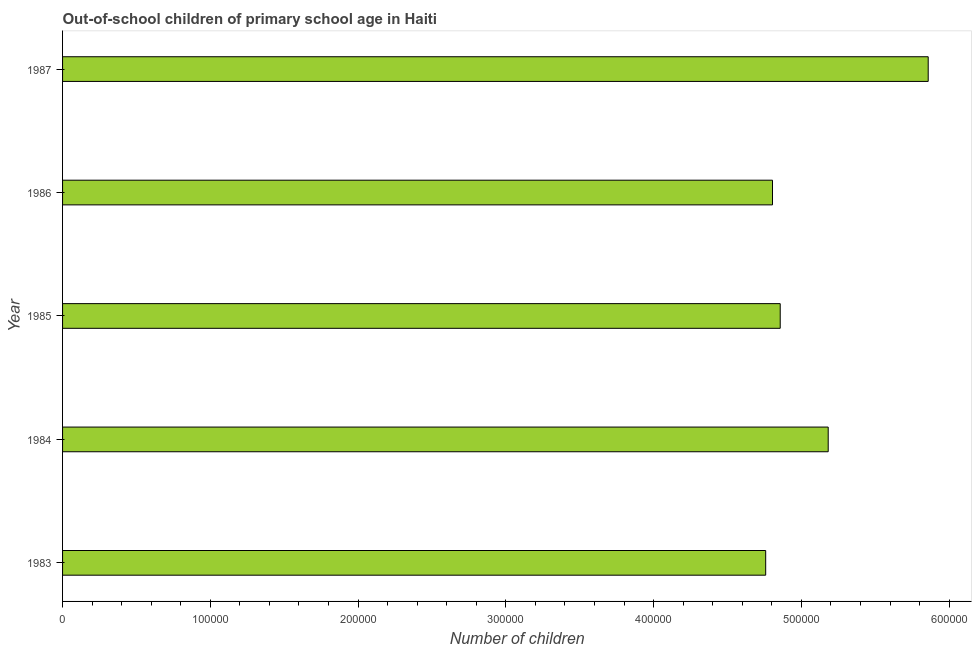Does the graph contain grids?
Make the answer very short. No. What is the title of the graph?
Ensure brevity in your answer.  Out-of-school children of primary school age in Haiti. What is the label or title of the X-axis?
Offer a very short reply. Number of children. What is the number of out-of-school children in 1985?
Offer a terse response. 4.86e+05. Across all years, what is the maximum number of out-of-school children?
Provide a succinct answer. 5.86e+05. Across all years, what is the minimum number of out-of-school children?
Offer a very short reply. 4.76e+05. In which year was the number of out-of-school children maximum?
Provide a short and direct response. 1987. What is the sum of the number of out-of-school children?
Keep it short and to the point. 2.55e+06. What is the difference between the number of out-of-school children in 1984 and 1986?
Ensure brevity in your answer.  3.77e+04. What is the average number of out-of-school children per year?
Your answer should be very brief. 5.09e+05. What is the median number of out-of-school children?
Offer a terse response. 4.86e+05. Do a majority of the years between 1986 and 1983 (inclusive) have number of out-of-school children greater than 400000 ?
Offer a terse response. Yes. Is the number of out-of-school children in 1984 less than that in 1987?
Give a very brief answer. Yes. What is the difference between the highest and the second highest number of out-of-school children?
Your answer should be very brief. 6.77e+04. What is the difference between the highest and the lowest number of out-of-school children?
Provide a succinct answer. 1.10e+05. In how many years, is the number of out-of-school children greater than the average number of out-of-school children taken over all years?
Offer a terse response. 2. How many years are there in the graph?
Ensure brevity in your answer.  5. What is the difference between two consecutive major ticks on the X-axis?
Ensure brevity in your answer.  1.00e+05. Are the values on the major ticks of X-axis written in scientific E-notation?
Offer a very short reply. No. What is the Number of children in 1983?
Make the answer very short. 4.76e+05. What is the Number of children of 1984?
Make the answer very short. 5.18e+05. What is the Number of children of 1985?
Provide a short and direct response. 4.86e+05. What is the Number of children of 1986?
Offer a terse response. 4.80e+05. What is the Number of children of 1987?
Your response must be concise. 5.86e+05. What is the difference between the Number of children in 1983 and 1984?
Ensure brevity in your answer.  -4.23e+04. What is the difference between the Number of children in 1983 and 1985?
Your answer should be very brief. -9827. What is the difference between the Number of children in 1983 and 1986?
Provide a short and direct response. -4612. What is the difference between the Number of children in 1983 and 1987?
Provide a succinct answer. -1.10e+05. What is the difference between the Number of children in 1984 and 1985?
Give a very brief answer. 3.25e+04. What is the difference between the Number of children in 1984 and 1986?
Offer a terse response. 3.77e+04. What is the difference between the Number of children in 1984 and 1987?
Ensure brevity in your answer.  -6.77e+04. What is the difference between the Number of children in 1985 and 1986?
Make the answer very short. 5215. What is the difference between the Number of children in 1985 and 1987?
Your response must be concise. -1.00e+05. What is the difference between the Number of children in 1986 and 1987?
Offer a very short reply. -1.05e+05. What is the ratio of the Number of children in 1983 to that in 1984?
Your answer should be compact. 0.92. What is the ratio of the Number of children in 1983 to that in 1986?
Offer a very short reply. 0.99. What is the ratio of the Number of children in 1983 to that in 1987?
Your response must be concise. 0.81. What is the ratio of the Number of children in 1984 to that in 1985?
Your response must be concise. 1.07. What is the ratio of the Number of children in 1984 to that in 1986?
Your response must be concise. 1.08. What is the ratio of the Number of children in 1984 to that in 1987?
Your answer should be compact. 0.88. What is the ratio of the Number of children in 1985 to that in 1987?
Make the answer very short. 0.83. What is the ratio of the Number of children in 1986 to that in 1987?
Keep it short and to the point. 0.82. 